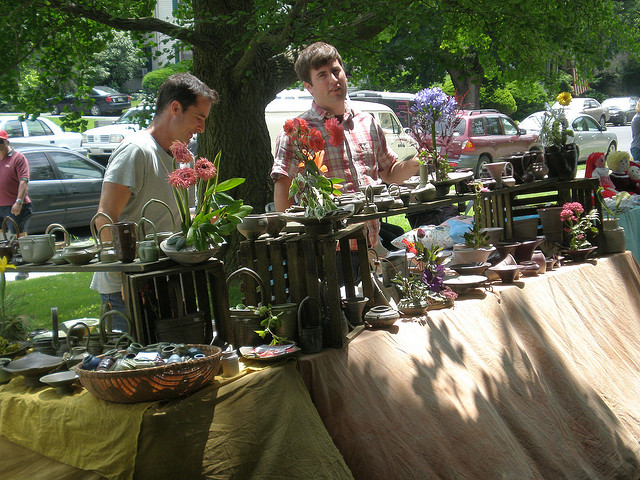<image>What event is taking place in the picture? I don't know what event is taking place in the picture. It could be a yard sale, plant show, flea market, or a picnic. What event is taking place in the picture? I don't know what event is taking place in the picture. It can be a yard sale, plant show, flea market, or picnic. 